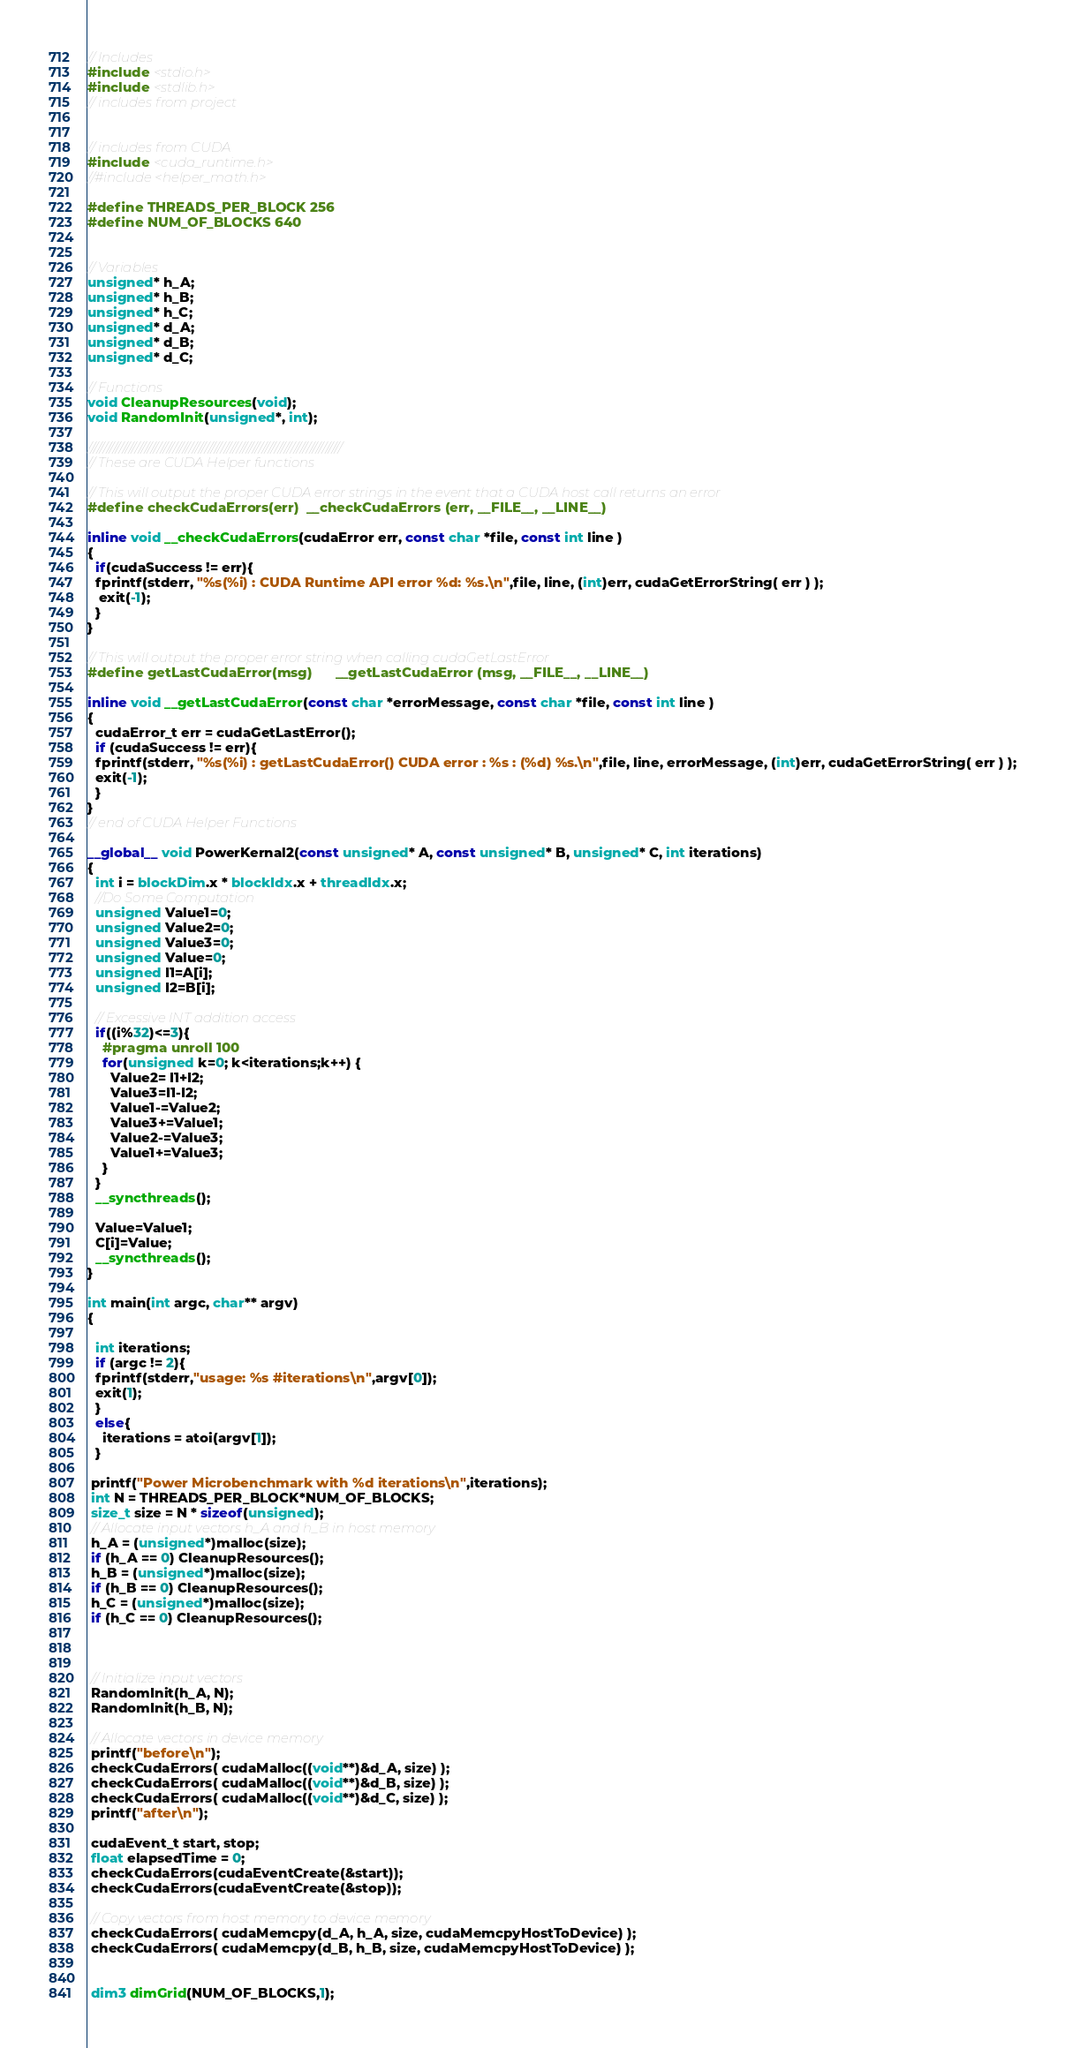Convert code to text. <code><loc_0><loc_0><loc_500><loc_500><_Cuda_>// Includes
#include <stdio.h>
#include <stdlib.h>
// includes from project


// includes from CUDA
#include <cuda_runtime.h>
//#include <helper_math.h>

#define THREADS_PER_BLOCK 256
#define NUM_OF_BLOCKS 640


// Variables
unsigned* h_A;
unsigned* h_B;
unsigned* h_C;
unsigned* d_A;
unsigned* d_B;
unsigned* d_C;

// Functions
void CleanupResources(void);
void RandomInit(unsigned*, int);

////////////////////////////////////////////////////////////////////////////////
// These are CUDA Helper functions

// This will output the proper CUDA error strings in the event that a CUDA host call returns an error
#define checkCudaErrors(err)  __checkCudaErrors (err, __FILE__, __LINE__)

inline void __checkCudaErrors(cudaError err, const char *file, const int line )
{
  if(cudaSuccess != err){
  fprintf(stderr, "%s(%i) : CUDA Runtime API error %d: %s.\n",file, line, (int)err, cudaGetErrorString( err ) );
   exit(-1);
  }
}

// This will output the proper error string when calling cudaGetLastError
#define getLastCudaError(msg)      __getLastCudaError (msg, __FILE__, __LINE__)

inline void __getLastCudaError(const char *errorMessage, const char *file, const int line )
{
  cudaError_t err = cudaGetLastError();
  if (cudaSuccess != err){
  fprintf(stderr, "%s(%i) : getLastCudaError() CUDA error : %s : (%d) %s.\n",file, line, errorMessage, (int)err, cudaGetErrorString( err ) );
  exit(-1);
  }
}
// end of CUDA Helper Functions

__global__ void PowerKernal2(const unsigned* A, const unsigned* B, unsigned* C, int iterations)
{
  int i = blockDim.x * blockIdx.x + threadIdx.x;
  //Do Some Computation
  unsigned Value1=0;
  unsigned Value2=0;
  unsigned Value3=0;
  unsigned Value=0;
  unsigned I1=A[i];
  unsigned I2=B[i];

  // Excessive INT addition access
  if((i%32)<=3){
    #pragma unroll 100
    for(unsigned k=0; k<iterations;k++) {
      Value2= I1+I2;
      Value3=I1-I2;
      Value1-=Value2;
      Value3+=Value1;
      Value2-=Value3;
      Value1+=Value3;
    }
  }
  __syncthreads();

  Value=Value1;
  C[i]=Value;
  __syncthreads();
}

int main(int argc, char** argv) 
{

  int iterations;
  if (argc != 2){
  fprintf(stderr,"usage: %s #iterations\n",argv[0]);
  exit(1);
  }
  else{
    iterations = atoi(argv[1]);
  }

 printf("Power Microbenchmark with %d iterations\n",iterations);
 int N = THREADS_PER_BLOCK*NUM_OF_BLOCKS;
 size_t size = N * sizeof(unsigned);
 // Allocate input vectors h_A and h_B in host memory
 h_A = (unsigned*)malloc(size);
 if (h_A == 0) CleanupResources();
 h_B = (unsigned*)malloc(size);
 if (h_B == 0) CleanupResources();
 h_C = (unsigned*)malloc(size);
 if (h_C == 0) CleanupResources();



 // Initialize input vectors
 RandomInit(h_A, N);
 RandomInit(h_B, N);

 // Allocate vectors in device memory
 printf("before\n");
 checkCudaErrors( cudaMalloc((void**)&d_A, size) );
 checkCudaErrors( cudaMalloc((void**)&d_B, size) );
 checkCudaErrors( cudaMalloc((void**)&d_C, size) );
 printf("after\n");

 cudaEvent_t start, stop;
 float elapsedTime = 0;
 checkCudaErrors(cudaEventCreate(&start));
 checkCudaErrors(cudaEventCreate(&stop));

 // Copy vectors from host memory to device memory
 checkCudaErrors( cudaMemcpy(d_A, h_A, size, cudaMemcpyHostToDevice) );
 checkCudaErrors( cudaMemcpy(d_B, h_B, size, cudaMemcpyHostToDevice) );


 dim3 dimGrid(NUM_OF_BLOCKS,1);</code> 